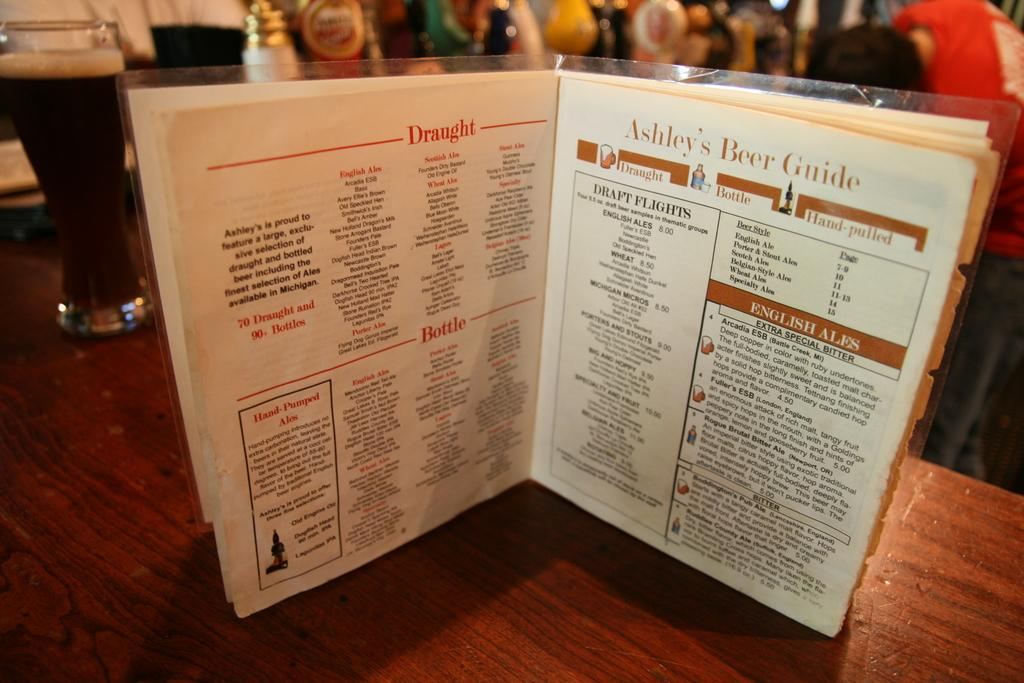<image>
Share a concise interpretation of the image provided. Abby's Beer Guide sits open on a table next to pints of ale. 